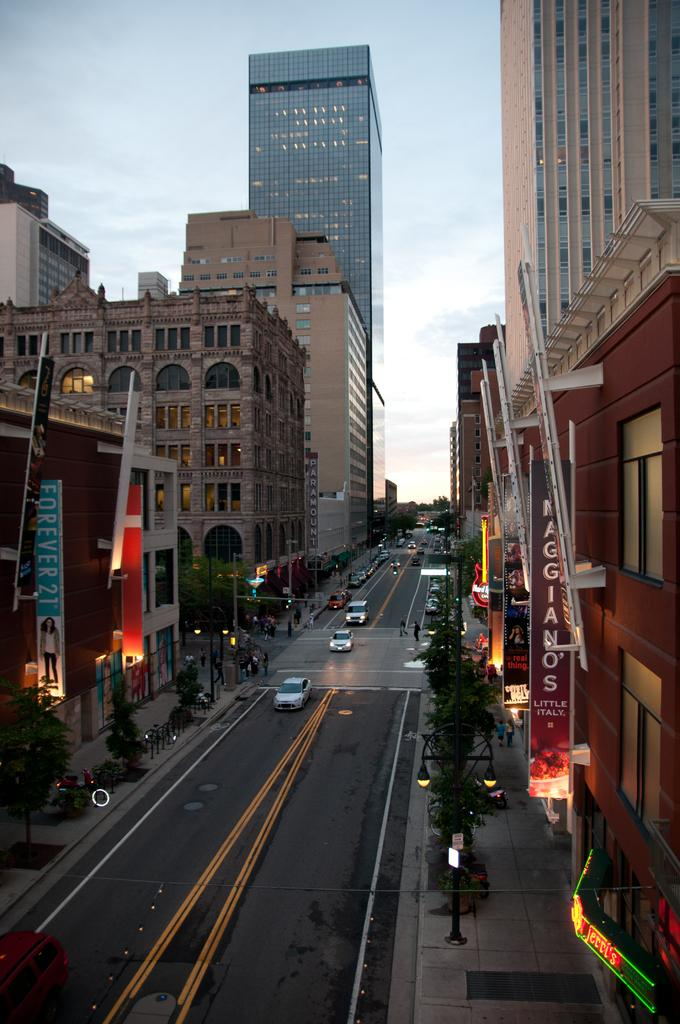Where was the image taken? The image was taken in a city. What can be seen at the bottom of the image? There is a road at the bottom of the image. What is moving on the road? Cars are present on the road. What type of structures are visible on both sides of the image? There are buildings and skyscrapers to the left and right of the image. What is visible at the top of the image? The sky is visible at the top of the image. What type of donkey can be seen carrying a title in the image? There is no donkey or title present in the image. What kind of rock is visible in the image? There is no rock visible in the image. 